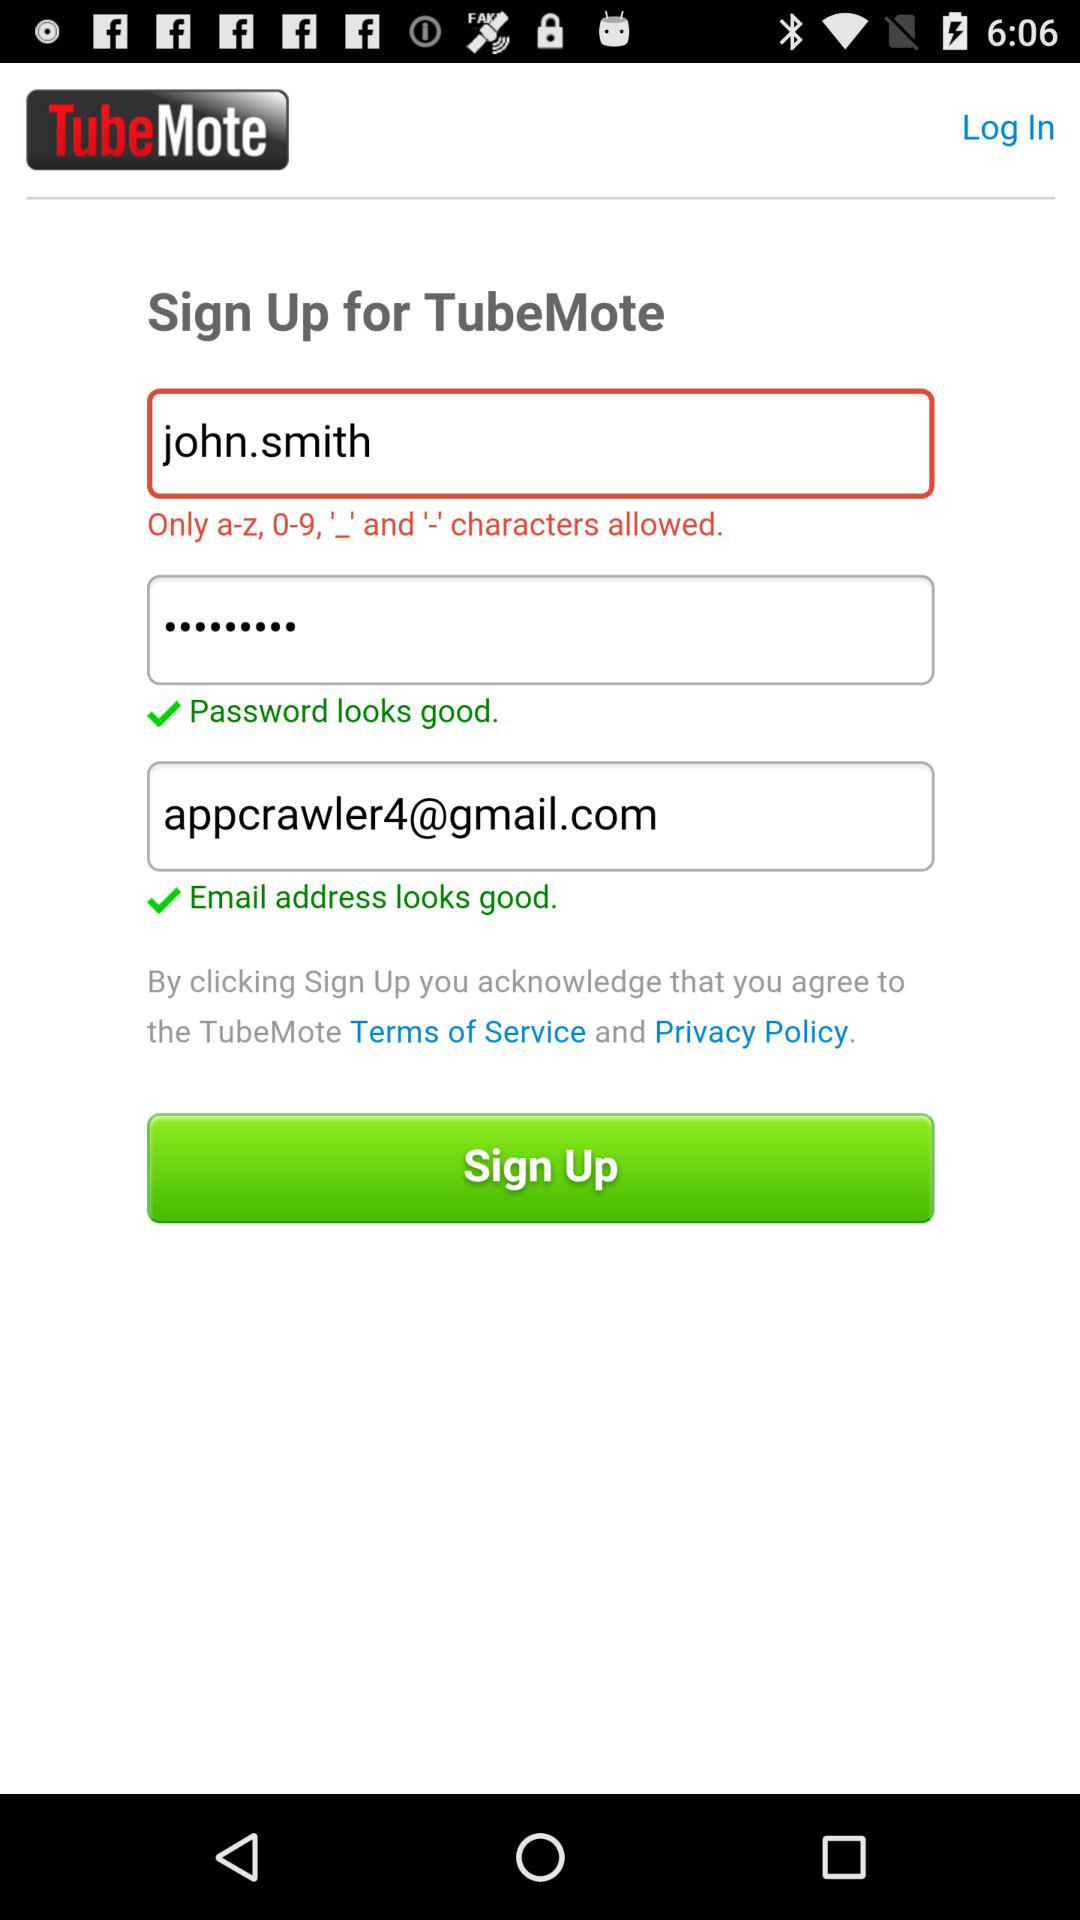What is the username? The username is "john.smith". 